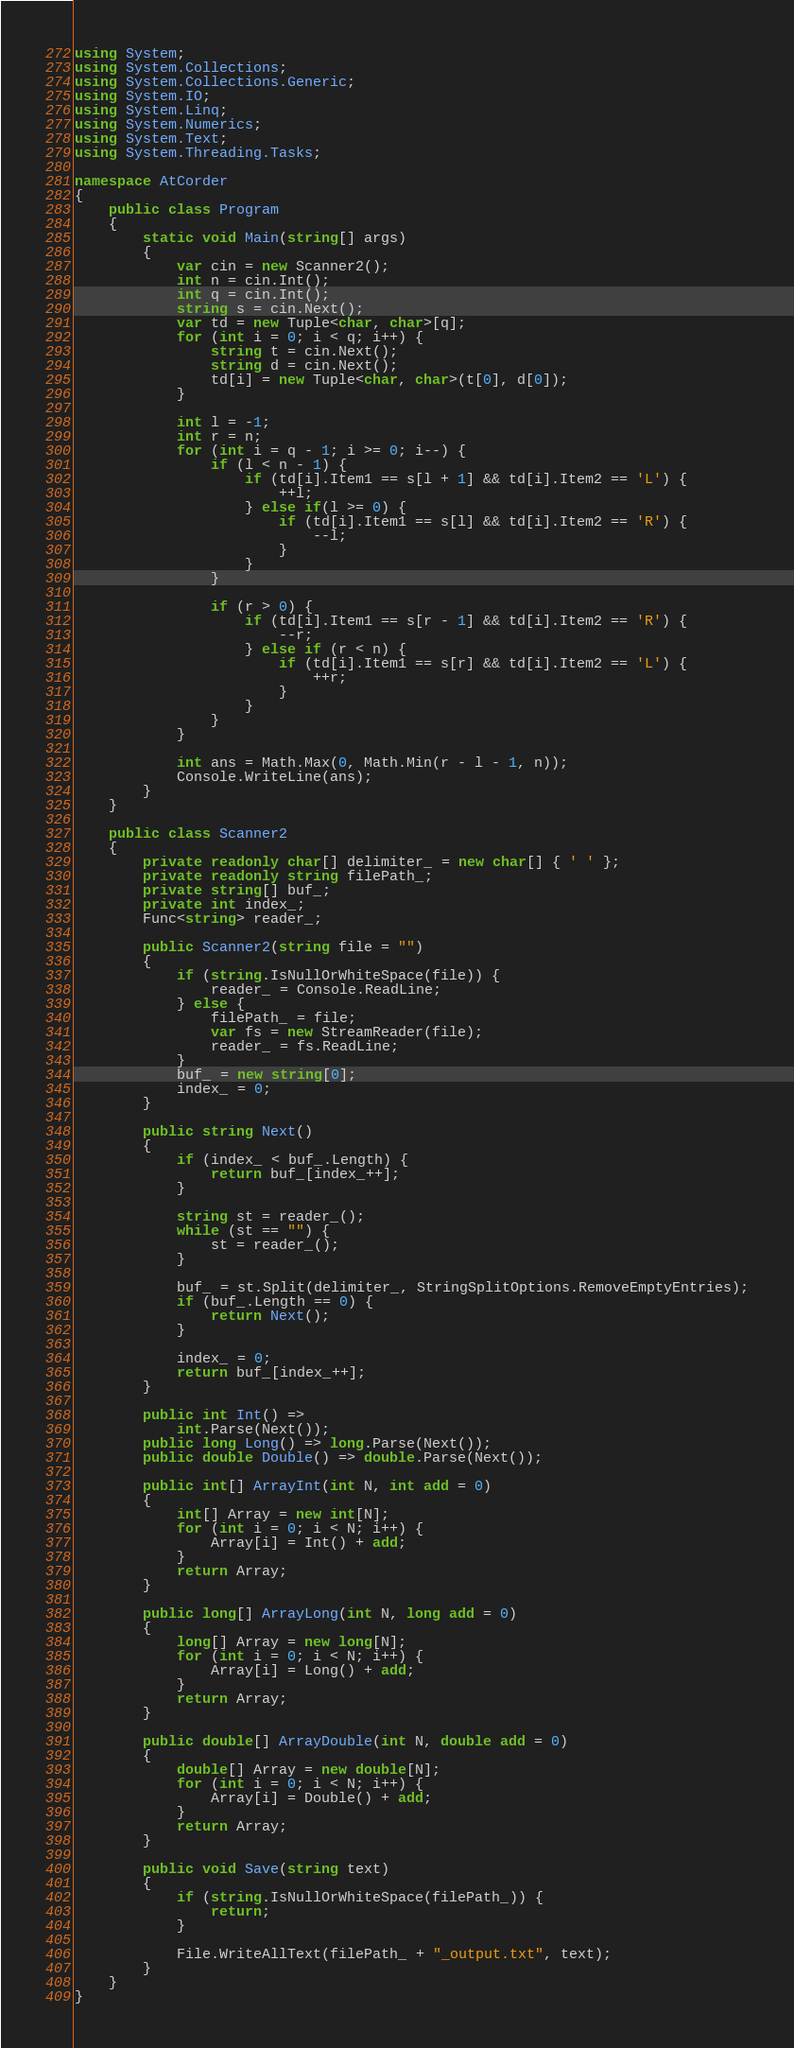<code> <loc_0><loc_0><loc_500><loc_500><_C#_>using System;
using System.Collections;
using System.Collections.Generic;
using System.IO;
using System.Linq;
using System.Numerics;
using System.Text;
using System.Threading.Tasks;

namespace AtCorder
{
	public class Program
	{
		static void Main(string[] args)
		{
			var cin = new Scanner2();
			int n = cin.Int();
			int q = cin.Int();
			string s = cin.Next();
			var td = new Tuple<char, char>[q];
			for (int i = 0; i < q; i++) {
				string t = cin.Next();
				string d = cin.Next();
				td[i] = new Tuple<char, char>(t[0], d[0]);
			}

			int l = -1;
			int r = n;
			for (int i = q - 1; i >= 0; i--) {
				if (l < n - 1) {
					if (td[i].Item1 == s[l + 1] && td[i].Item2 == 'L') {
						++l;
					} else if(l >= 0) {
						if (td[i].Item1 == s[l] && td[i].Item2 == 'R') {
							--l;
						}
					}
				}

				if (r > 0) {
					if (td[i].Item1 == s[r - 1] && td[i].Item2 == 'R') {
						--r;
					} else if (r < n) {
						if (td[i].Item1 == s[r] && td[i].Item2 == 'L') {
							++r;
						}
					}
				}
			}

			int ans = Math.Max(0, Math.Min(r - l - 1, n));
			Console.WriteLine(ans);
		}
	}

	public class Scanner2
	{
		private readonly char[] delimiter_ = new char[] { ' ' };
		private readonly string filePath_;
		private string[] buf_;
		private int index_;
		Func<string> reader_;

		public Scanner2(string file = "")
		{
			if (string.IsNullOrWhiteSpace(file)) {
				reader_ = Console.ReadLine;
			} else {
				filePath_ = file;
				var fs = new StreamReader(file);
				reader_ = fs.ReadLine;
			}
			buf_ = new string[0];
			index_ = 0;
		}

		public string Next()
		{
			if (index_ < buf_.Length) {
				return buf_[index_++];
			}

			string st = reader_();
			while (st == "") {
				st = reader_();
			}

			buf_ = st.Split(delimiter_, StringSplitOptions.RemoveEmptyEntries);
			if (buf_.Length == 0) {
				return Next();
			}

			index_ = 0;
			return buf_[index_++];
		}

		public int Int() => 
			int.Parse(Next());
		public long Long() => long.Parse(Next());
		public double Double() => double.Parse(Next());

		public int[] ArrayInt(int N, int add = 0)
		{
			int[] Array = new int[N];
			for (int i = 0; i < N; i++) {
				Array[i] = Int() + add;
			}
			return Array;
		}

		public long[] ArrayLong(int N, long add = 0)
		{
			long[] Array = new long[N];
			for (int i = 0; i < N; i++) {
				Array[i] = Long() + add;
			}
			return Array;
		}

		public double[] ArrayDouble(int N, double add = 0)
		{
			double[] Array = new double[N];
			for (int i = 0; i < N; i++) {
				Array[i] = Double() + add;
			}
			return Array;
		}

		public void Save(string text)
		{
			if (string.IsNullOrWhiteSpace(filePath_)) {
				return;
			}

			File.WriteAllText(filePath_ + "_output.txt", text);
		}
	}
}</code> 